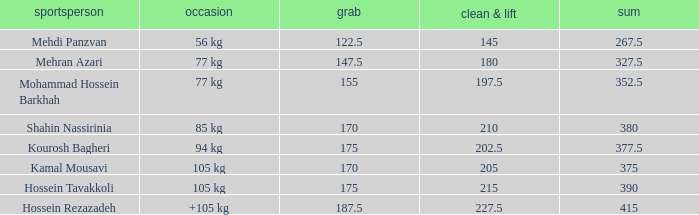What is the total that had an event of +105 kg and clean & jerk less than 227.5? 0.0. 